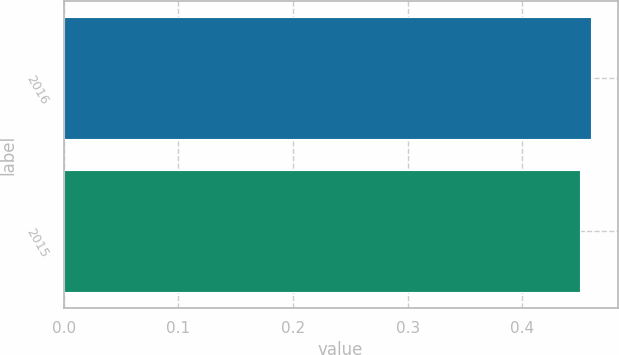Convert chart to OTSL. <chart><loc_0><loc_0><loc_500><loc_500><bar_chart><fcel>2016<fcel>2015<nl><fcel>0.46<fcel>0.45<nl></chart> 